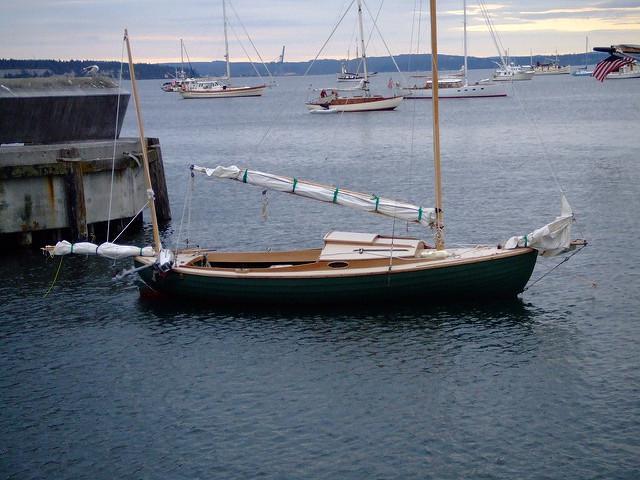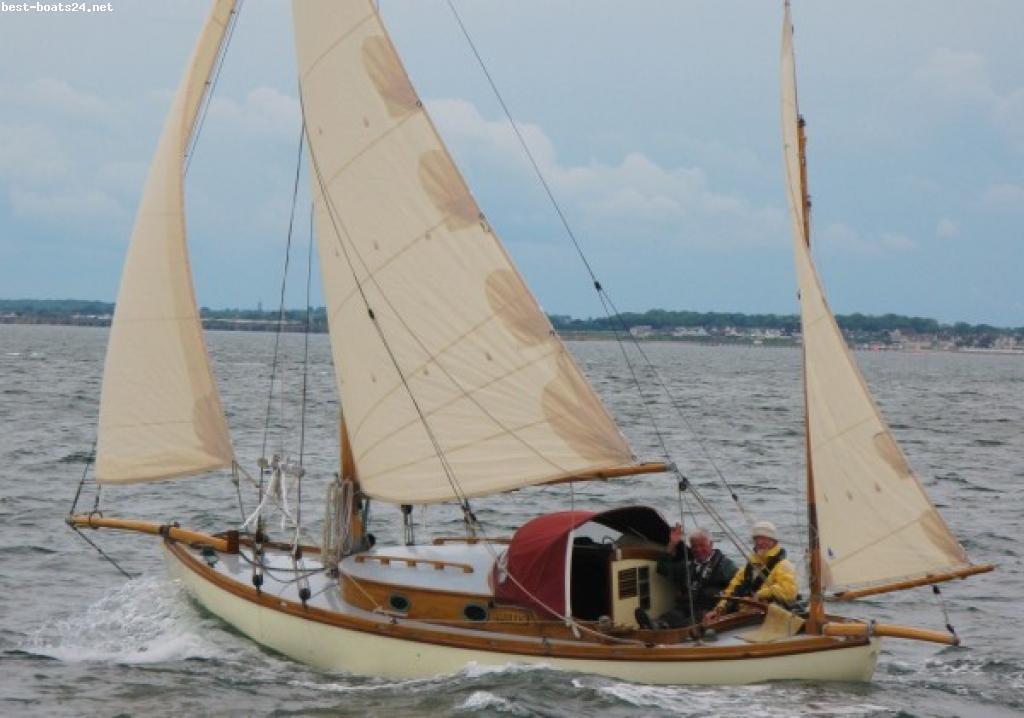The first image is the image on the left, the second image is the image on the right. Evaluate the accuracy of this statement regarding the images: "There is a sailboat out in open water in the center of both images.". Is it true? Answer yes or no. No. The first image is the image on the left, the second image is the image on the right. Examine the images to the left and right. Is the description "In at least one image shows a boat with a visible name on its hull." accurate? Answer yes or no. No. 